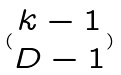<formula> <loc_0><loc_0><loc_500><loc_500>( \begin{matrix} k - 1 \\ D - 1 \end{matrix} )</formula> 